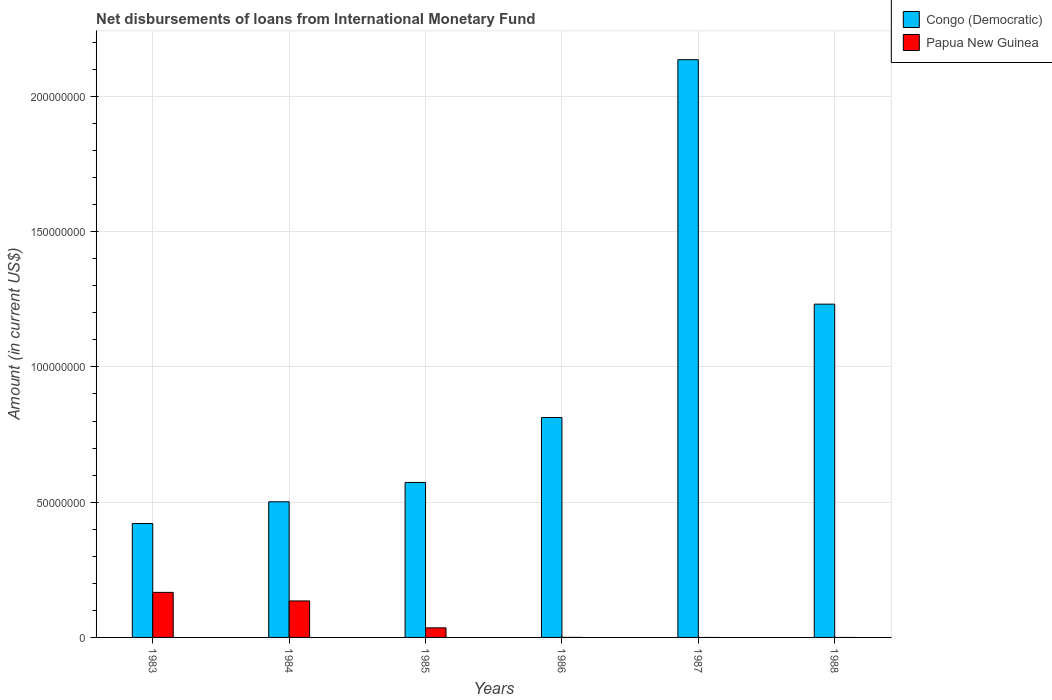How many different coloured bars are there?
Offer a terse response. 2. Are the number of bars on each tick of the X-axis equal?
Your response must be concise. No. What is the label of the 4th group of bars from the left?
Provide a succinct answer. 1986. In how many cases, is the number of bars for a given year not equal to the number of legend labels?
Ensure brevity in your answer.  3. What is the amount of loans disbursed in Congo (Democratic) in 1987?
Keep it short and to the point. 2.14e+08. Across all years, what is the maximum amount of loans disbursed in Congo (Democratic)?
Your response must be concise. 2.14e+08. Across all years, what is the minimum amount of loans disbursed in Congo (Democratic)?
Offer a terse response. 4.21e+07. In which year was the amount of loans disbursed in Congo (Democratic) maximum?
Make the answer very short. 1987. What is the total amount of loans disbursed in Congo (Democratic) in the graph?
Give a very brief answer. 5.68e+08. What is the difference between the amount of loans disbursed in Congo (Democratic) in 1983 and that in 1984?
Make the answer very short. -8.03e+06. What is the difference between the amount of loans disbursed in Papua New Guinea in 1988 and the amount of loans disbursed in Congo (Democratic) in 1983?
Provide a succinct answer. -4.21e+07. What is the average amount of loans disbursed in Congo (Democratic) per year?
Provide a succinct answer. 9.46e+07. In the year 1984, what is the difference between the amount of loans disbursed in Congo (Democratic) and amount of loans disbursed in Papua New Guinea?
Provide a short and direct response. 3.67e+07. In how many years, is the amount of loans disbursed in Congo (Democratic) greater than 100000000 US$?
Give a very brief answer. 2. What is the ratio of the amount of loans disbursed in Papua New Guinea in 1983 to that in 1984?
Your response must be concise. 1.24. Is the amount of loans disbursed in Congo (Democratic) in 1983 less than that in 1988?
Keep it short and to the point. Yes. Is the difference between the amount of loans disbursed in Congo (Democratic) in 1983 and 1985 greater than the difference between the amount of loans disbursed in Papua New Guinea in 1983 and 1985?
Your response must be concise. No. What is the difference between the highest and the second highest amount of loans disbursed in Papua New Guinea?
Make the answer very short. 3.17e+06. What is the difference between the highest and the lowest amount of loans disbursed in Congo (Democratic)?
Provide a short and direct response. 1.71e+08. In how many years, is the amount of loans disbursed in Papua New Guinea greater than the average amount of loans disbursed in Papua New Guinea taken over all years?
Keep it short and to the point. 2. How many bars are there?
Keep it short and to the point. 9. How many years are there in the graph?
Offer a very short reply. 6. What is the difference between two consecutive major ticks on the Y-axis?
Keep it short and to the point. 5.00e+07. Does the graph contain grids?
Your answer should be very brief. Yes. Where does the legend appear in the graph?
Offer a very short reply. Top right. How many legend labels are there?
Your answer should be compact. 2. How are the legend labels stacked?
Ensure brevity in your answer.  Vertical. What is the title of the graph?
Your response must be concise. Net disbursements of loans from International Monetary Fund. What is the label or title of the X-axis?
Keep it short and to the point. Years. What is the label or title of the Y-axis?
Your answer should be compact. Amount (in current US$). What is the Amount (in current US$) in Congo (Democratic) in 1983?
Provide a succinct answer. 4.21e+07. What is the Amount (in current US$) of Papua New Guinea in 1983?
Your answer should be compact. 1.67e+07. What is the Amount (in current US$) in Congo (Democratic) in 1984?
Ensure brevity in your answer.  5.01e+07. What is the Amount (in current US$) of Papua New Guinea in 1984?
Offer a terse response. 1.35e+07. What is the Amount (in current US$) in Congo (Democratic) in 1985?
Keep it short and to the point. 5.73e+07. What is the Amount (in current US$) of Papua New Guinea in 1985?
Your answer should be compact. 3.54e+06. What is the Amount (in current US$) in Congo (Democratic) in 1986?
Give a very brief answer. 8.13e+07. What is the Amount (in current US$) in Papua New Guinea in 1986?
Make the answer very short. 0. What is the Amount (in current US$) in Congo (Democratic) in 1987?
Give a very brief answer. 2.14e+08. What is the Amount (in current US$) in Congo (Democratic) in 1988?
Provide a succinct answer. 1.23e+08. Across all years, what is the maximum Amount (in current US$) of Congo (Democratic)?
Your response must be concise. 2.14e+08. Across all years, what is the maximum Amount (in current US$) of Papua New Guinea?
Your response must be concise. 1.67e+07. Across all years, what is the minimum Amount (in current US$) in Congo (Democratic)?
Make the answer very short. 4.21e+07. What is the total Amount (in current US$) in Congo (Democratic) in the graph?
Provide a succinct answer. 5.68e+08. What is the total Amount (in current US$) of Papua New Guinea in the graph?
Your answer should be very brief. 3.37e+07. What is the difference between the Amount (in current US$) of Congo (Democratic) in 1983 and that in 1984?
Your answer should be very brief. -8.03e+06. What is the difference between the Amount (in current US$) in Papua New Guinea in 1983 and that in 1984?
Your answer should be very brief. 3.17e+06. What is the difference between the Amount (in current US$) of Congo (Democratic) in 1983 and that in 1985?
Ensure brevity in your answer.  -1.52e+07. What is the difference between the Amount (in current US$) of Papua New Guinea in 1983 and that in 1985?
Offer a terse response. 1.31e+07. What is the difference between the Amount (in current US$) of Congo (Democratic) in 1983 and that in 1986?
Offer a terse response. -3.92e+07. What is the difference between the Amount (in current US$) of Congo (Democratic) in 1983 and that in 1987?
Ensure brevity in your answer.  -1.71e+08. What is the difference between the Amount (in current US$) in Congo (Democratic) in 1983 and that in 1988?
Provide a succinct answer. -8.11e+07. What is the difference between the Amount (in current US$) of Congo (Democratic) in 1984 and that in 1985?
Make the answer very short. -7.15e+06. What is the difference between the Amount (in current US$) in Papua New Guinea in 1984 and that in 1985?
Make the answer very short. 9.94e+06. What is the difference between the Amount (in current US$) of Congo (Democratic) in 1984 and that in 1986?
Your answer should be very brief. -3.11e+07. What is the difference between the Amount (in current US$) in Congo (Democratic) in 1984 and that in 1987?
Offer a terse response. -1.63e+08. What is the difference between the Amount (in current US$) in Congo (Democratic) in 1984 and that in 1988?
Your answer should be compact. -7.31e+07. What is the difference between the Amount (in current US$) in Congo (Democratic) in 1985 and that in 1986?
Your answer should be compact. -2.40e+07. What is the difference between the Amount (in current US$) in Congo (Democratic) in 1985 and that in 1987?
Offer a very short reply. -1.56e+08. What is the difference between the Amount (in current US$) of Congo (Democratic) in 1985 and that in 1988?
Ensure brevity in your answer.  -6.59e+07. What is the difference between the Amount (in current US$) of Congo (Democratic) in 1986 and that in 1987?
Give a very brief answer. -1.32e+08. What is the difference between the Amount (in current US$) of Congo (Democratic) in 1986 and that in 1988?
Provide a succinct answer. -4.19e+07. What is the difference between the Amount (in current US$) of Congo (Democratic) in 1987 and that in 1988?
Provide a short and direct response. 9.04e+07. What is the difference between the Amount (in current US$) of Congo (Democratic) in 1983 and the Amount (in current US$) of Papua New Guinea in 1984?
Your answer should be compact. 2.86e+07. What is the difference between the Amount (in current US$) in Congo (Democratic) in 1983 and the Amount (in current US$) in Papua New Guinea in 1985?
Your response must be concise. 3.86e+07. What is the difference between the Amount (in current US$) of Congo (Democratic) in 1984 and the Amount (in current US$) of Papua New Guinea in 1985?
Provide a short and direct response. 4.66e+07. What is the average Amount (in current US$) of Congo (Democratic) per year?
Your answer should be compact. 9.46e+07. What is the average Amount (in current US$) in Papua New Guinea per year?
Provide a short and direct response. 5.61e+06. In the year 1983, what is the difference between the Amount (in current US$) of Congo (Democratic) and Amount (in current US$) of Papua New Guinea?
Your response must be concise. 2.55e+07. In the year 1984, what is the difference between the Amount (in current US$) in Congo (Democratic) and Amount (in current US$) in Papua New Guinea?
Your answer should be very brief. 3.67e+07. In the year 1985, what is the difference between the Amount (in current US$) in Congo (Democratic) and Amount (in current US$) in Papua New Guinea?
Provide a short and direct response. 5.38e+07. What is the ratio of the Amount (in current US$) in Congo (Democratic) in 1983 to that in 1984?
Your answer should be very brief. 0.84. What is the ratio of the Amount (in current US$) of Papua New Guinea in 1983 to that in 1984?
Keep it short and to the point. 1.24. What is the ratio of the Amount (in current US$) of Congo (Democratic) in 1983 to that in 1985?
Give a very brief answer. 0.73. What is the ratio of the Amount (in current US$) of Papua New Guinea in 1983 to that in 1985?
Provide a short and direct response. 4.71. What is the ratio of the Amount (in current US$) in Congo (Democratic) in 1983 to that in 1986?
Offer a terse response. 0.52. What is the ratio of the Amount (in current US$) in Congo (Democratic) in 1983 to that in 1987?
Offer a terse response. 0.2. What is the ratio of the Amount (in current US$) in Congo (Democratic) in 1983 to that in 1988?
Your answer should be compact. 0.34. What is the ratio of the Amount (in current US$) in Congo (Democratic) in 1984 to that in 1985?
Your answer should be very brief. 0.88. What is the ratio of the Amount (in current US$) in Papua New Guinea in 1984 to that in 1985?
Ensure brevity in your answer.  3.81. What is the ratio of the Amount (in current US$) of Congo (Democratic) in 1984 to that in 1986?
Offer a very short reply. 0.62. What is the ratio of the Amount (in current US$) in Congo (Democratic) in 1984 to that in 1987?
Provide a short and direct response. 0.23. What is the ratio of the Amount (in current US$) in Congo (Democratic) in 1984 to that in 1988?
Provide a short and direct response. 0.41. What is the ratio of the Amount (in current US$) in Congo (Democratic) in 1985 to that in 1986?
Your answer should be compact. 0.7. What is the ratio of the Amount (in current US$) in Congo (Democratic) in 1985 to that in 1987?
Ensure brevity in your answer.  0.27. What is the ratio of the Amount (in current US$) in Congo (Democratic) in 1985 to that in 1988?
Offer a terse response. 0.47. What is the ratio of the Amount (in current US$) in Congo (Democratic) in 1986 to that in 1987?
Offer a very short reply. 0.38. What is the ratio of the Amount (in current US$) of Congo (Democratic) in 1986 to that in 1988?
Your answer should be compact. 0.66. What is the ratio of the Amount (in current US$) in Congo (Democratic) in 1987 to that in 1988?
Offer a very short reply. 1.73. What is the difference between the highest and the second highest Amount (in current US$) in Congo (Democratic)?
Your answer should be very brief. 9.04e+07. What is the difference between the highest and the second highest Amount (in current US$) of Papua New Guinea?
Keep it short and to the point. 3.17e+06. What is the difference between the highest and the lowest Amount (in current US$) of Congo (Democratic)?
Give a very brief answer. 1.71e+08. What is the difference between the highest and the lowest Amount (in current US$) in Papua New Guinea?
Ensure brevity in your answer.  1.67e+07. 